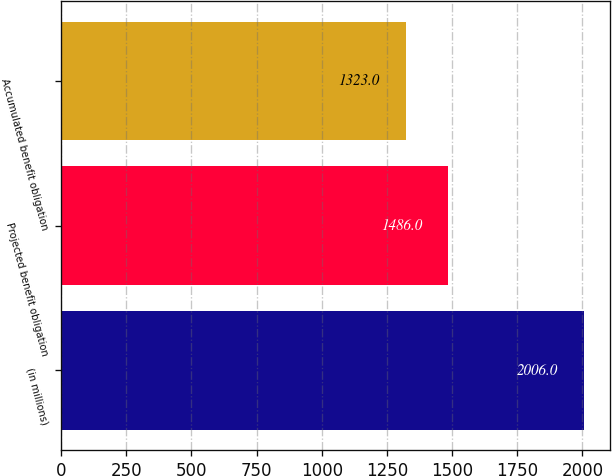Convert chart to OTSL. <chart><loc_0><loc_0><loc_500><loc_500><bar_chart><fcel>(in millions)<fcel>Projected benefit obligation<fcel>Accumulated benefit obligation<nl><fcel>2006<fcel>1486<fcel>1323<nl></chart> 